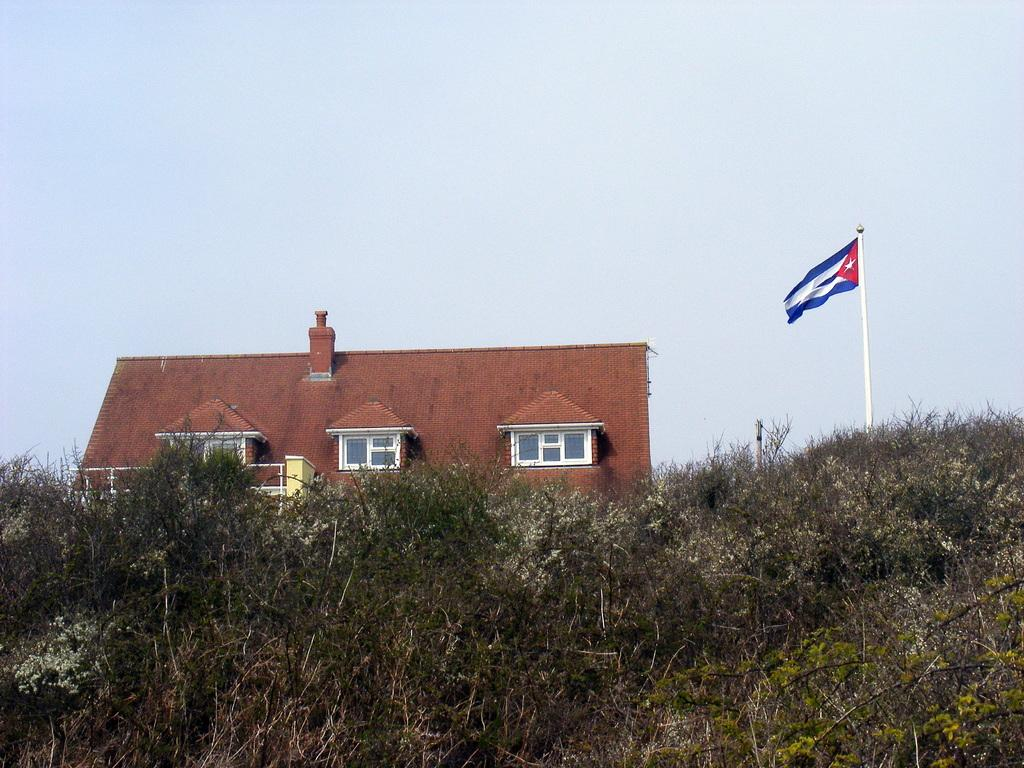What type of living organism can be seen in the image? There is a plant in the image. What structure is located behind the plant? There is a house behind the plant. What feature can be seen on the house? The house has railing. What is attached to the pole beside the plant? There is a flag on the pole beside the plant. What part of the natural environment is visible in the image? The sky is visible in the image. What type of orange can be seen growing on the plant in the image? There is no orange present on the plant in the image; it is a plant, not a citrus tree. 